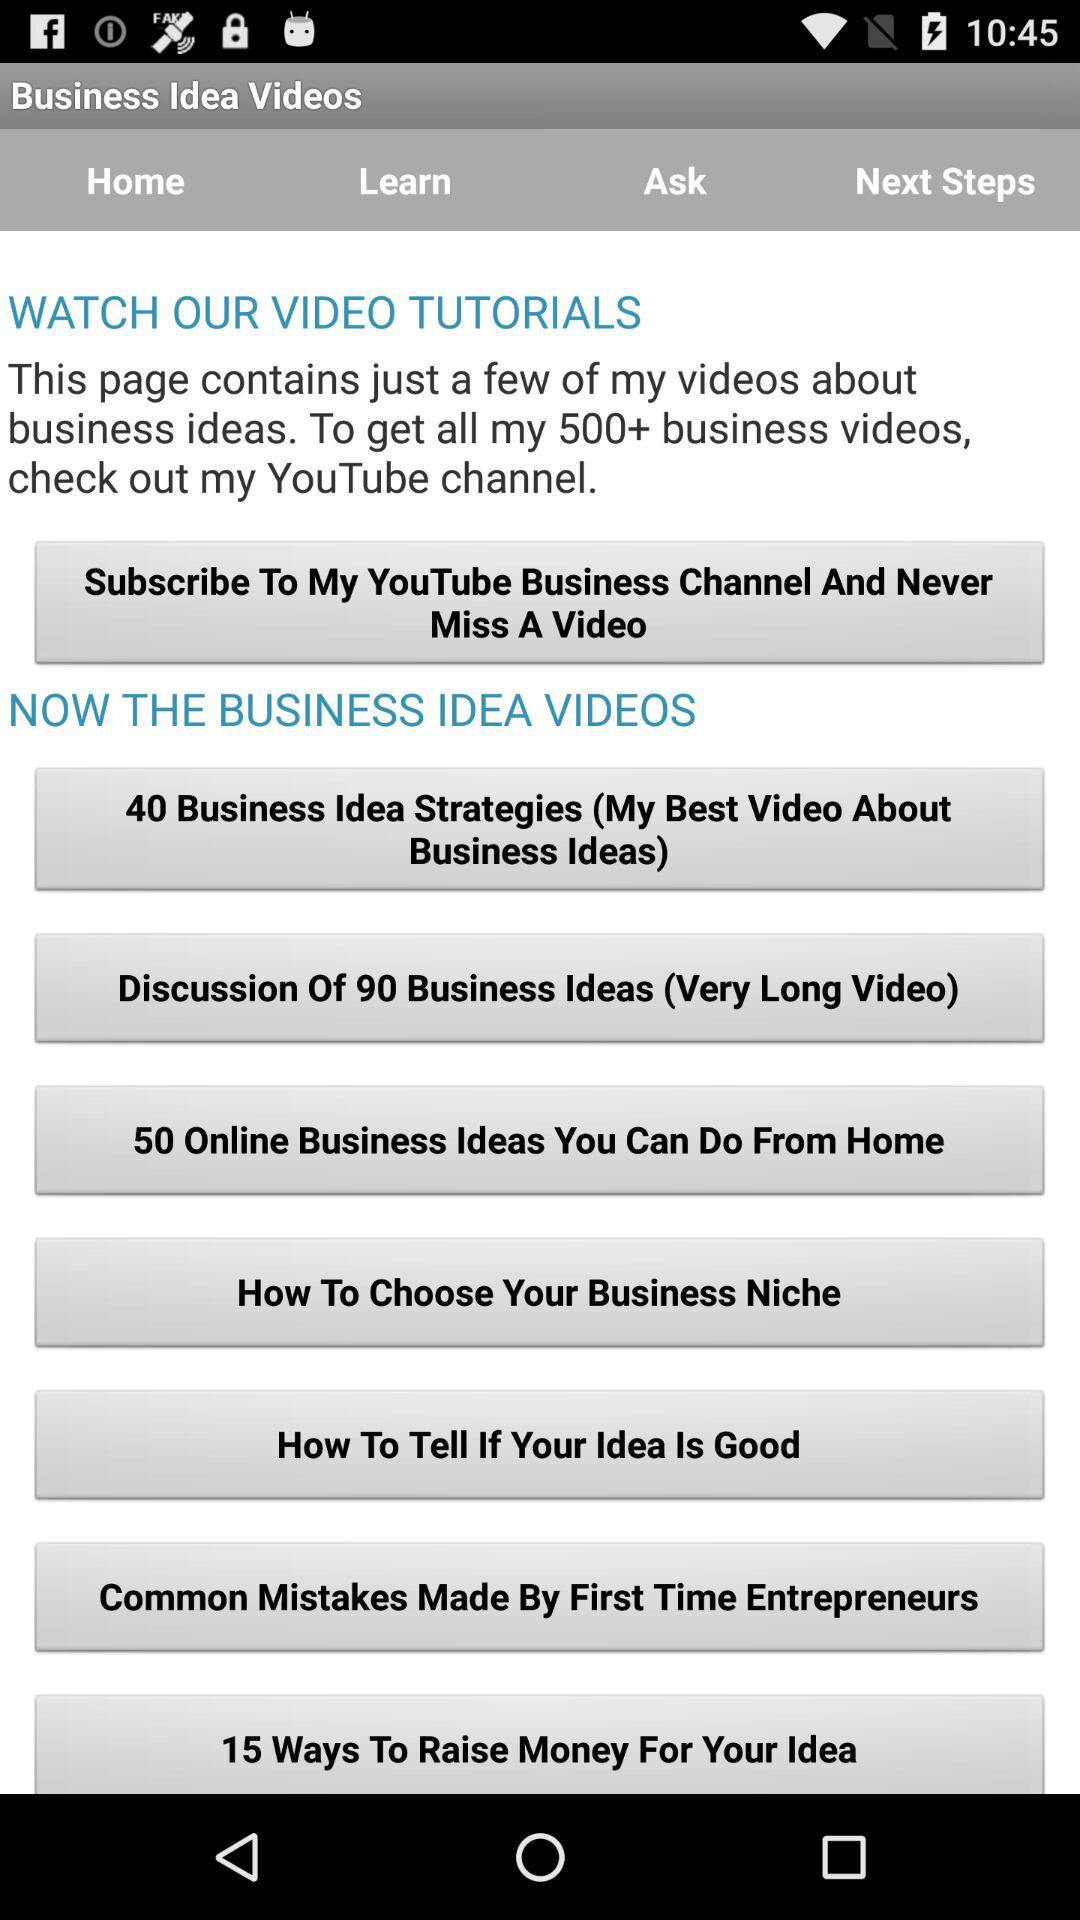What is the given number of business idea strategies?
When the provided information is insufficient, respond with <no answer>. <no answer> 